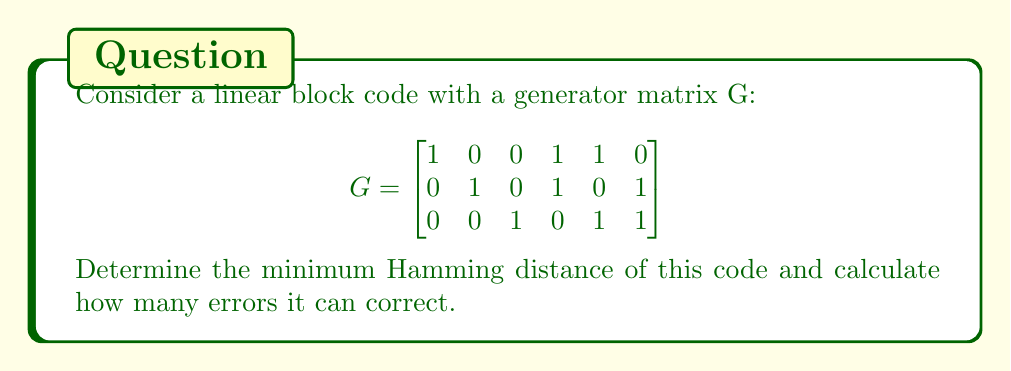Teach me how to tackle this problem. To solve this problem, we'll follow these steps:

1) First, we need to find all possible codewords. Since this is a (6,3) linear block code, there are $2^3 = 8$ codewords.

2) To generate all codewords, we multiply all possible 3-bit messages with the generator matrix G:

   $000 \cdot G = 000000$
   $100 \cdot G = 100110$
   $010 \cdot G = 010101$
   $001 \cdot G = 001011$
   $110 \cdot G = 110011$
   $101 \cdot G = 101101$
   $011 \cdot G = 011110$
   $111 \cdot G = 111000$

3) Now, we need to calculate the Hamming distance between each pair of codewords and find the minimum. The Hamming distance is the number of positions at which corresponding symbols in two codewords are different.

4) After comparing all pairs, we find that the minimum Hamming distance $d_{min} = 3$.

5) For a linear block code, the number of errors it can correct is given by:

   $t = \lfloor \frac{d_{min} - 1}{2} \rfloor$

   Where $\lfloor \cdot \rfloor$ denotes the floor function.

6) Substituting our $d_{min}$:

   $t = \lfloor \frac{3 - 1}{2} \rfloor = \lfloor 1 \rfloor = 1$

Therefore, this code can correct 1 error.
Answer: Minimum Hamming distance: 3; Can correct 1 error 